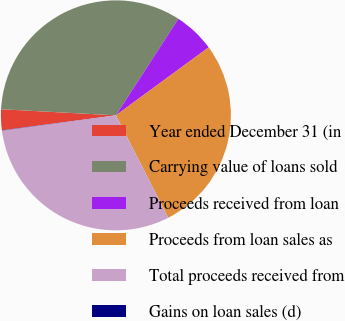<chart> <loc_0><loc_0><loc_500><loc_500><pie_chart><fcel>Year ended December 31 (in<fcel>Carrying value of loans sold<fcel>Proceeds received from loan<fcel>Proceeds from loan sales as<fcel>Total proceeds received from<fcel>Gains on loan sales (d)<nl><fcel>2.91%<fcel>33.29%<fcel>5.79%<fcel>27.54%<fcel>30.42%<fcel>0.04%<nl></chart> 